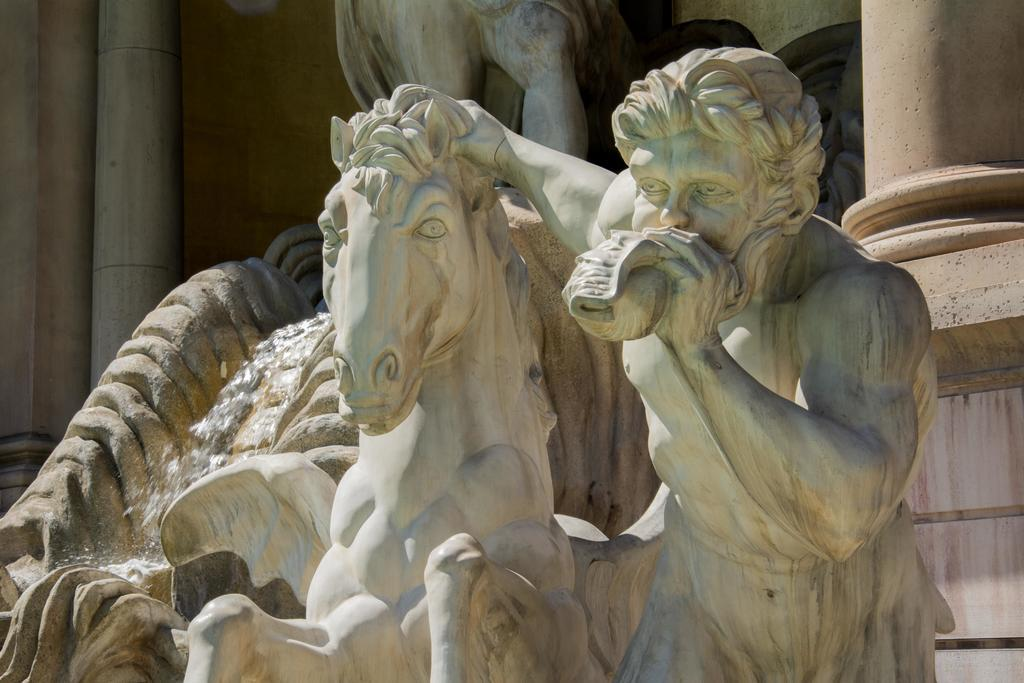What is the main subject of the sculpture in the image? The main subject of the sculpture is a man and a horse. What is happening in the image? Water is flowing in the image. What architectural elements can be seen in the image? There are pillars in the image. What color are the sculptures? The sculptures are white in color. What type of plastic is used to create the territory in the image? There is no territory or plastic present in the image; it features a sculpture of a man and a horse, water flowing, and pillars. 